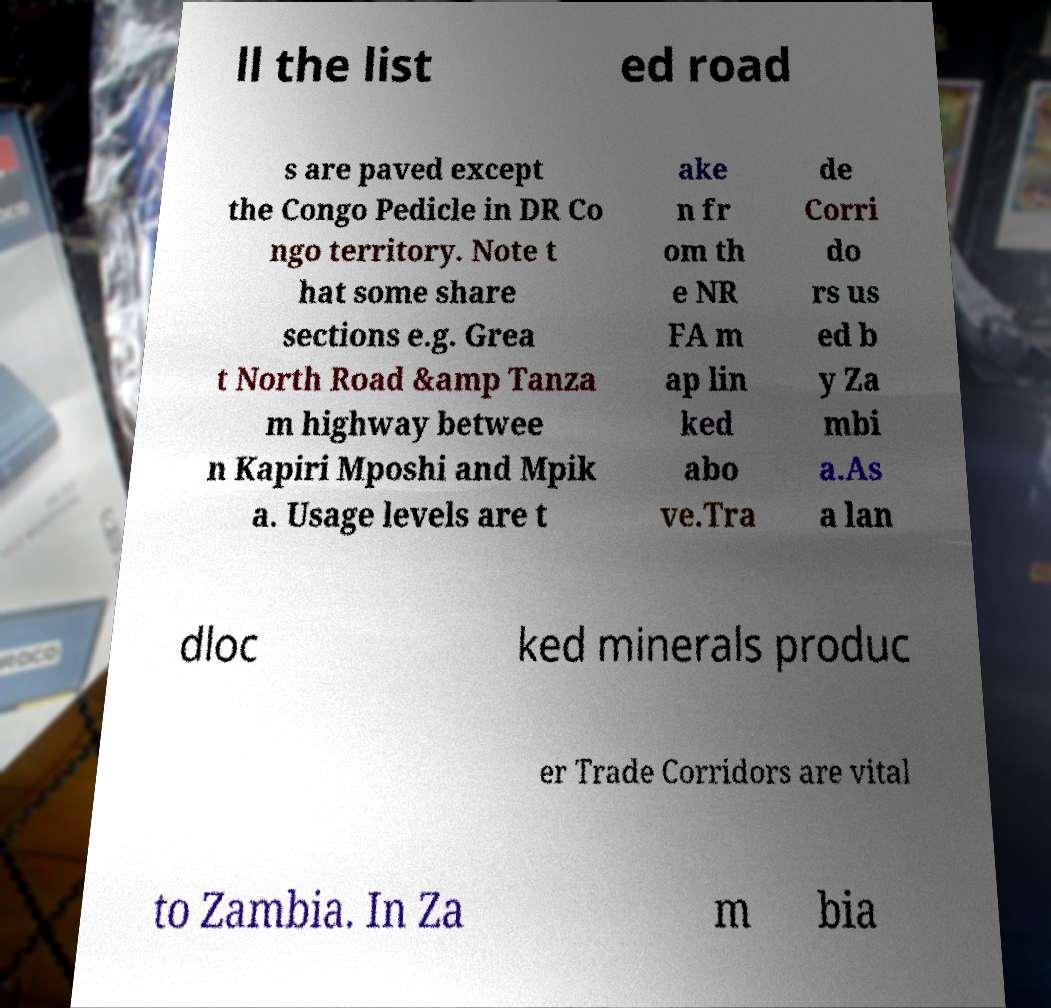Could you extract and type out the text from this image? ll the list ed road s are paved except the Congo Pedicle in DR Co ngo territory. Note t hat some share sections e.g. Grea t North Road &amp Tanza m highway betwee n Kapiri Mposhi and Mpik a. Usage levels are t ake n fr om th e NR FA m ap lin ked abo ve.Tra de Corri do rs us ed b y Za mbi a.As a lan dloc ked minerals produc er Trade Corridors are vital to Zambia. In Za m bia 